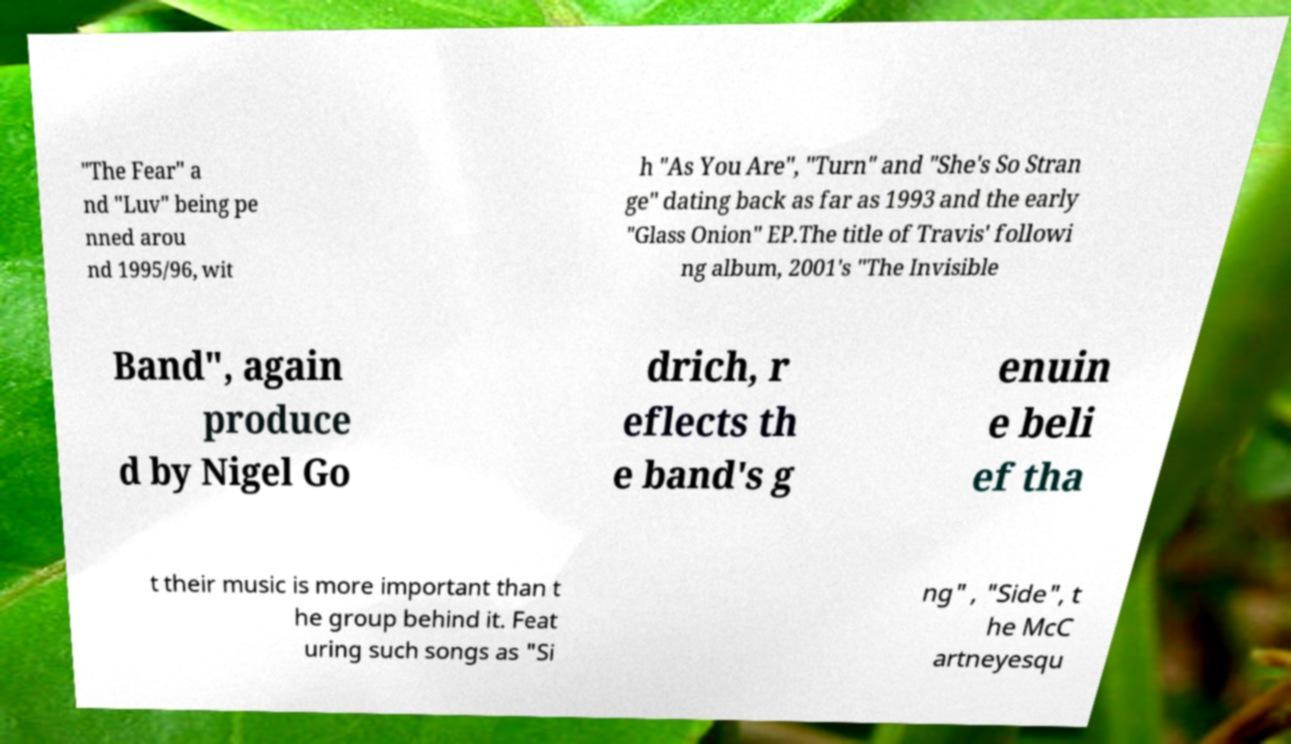Could you extract and type out the text from this image? "The Fear" a nd "Luv" being pe nned arou nd 1995/96, wit h "As You Are", "Turn" and "She's So Stran ge" dating back as far as 1993 and the early "Glass Onion" EP.The title of Travis' followi ng album, 2001's "The Invisible Band", again produce d by Nigel Go drich, r eflects th e band's g enuin e beli ef tha t their music is more important than t he group behind it. Feat uring such songs as "Si ng" , "Side", t he McC artneyesqu 